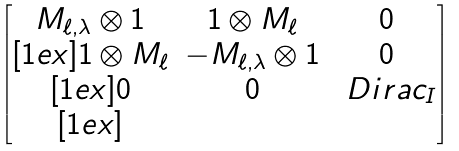<formula> <loc_0><loc_0><loc_500><loc_500>\begin{bmatrix} M _ { \ell , \lambda } \otimes 1 & 1 \otimes M _ { \ell } & 0 \\ [ 1 e x ] 1 \otimes M _ { \ell } & - M _ { \ell , \lambda } \otimes 1 & 0 \\ [ 1 e x ] 0 & 0 & \ D i r a c _ { I } \\ [ 1 e x ] \end{bmatrix}</formula> 